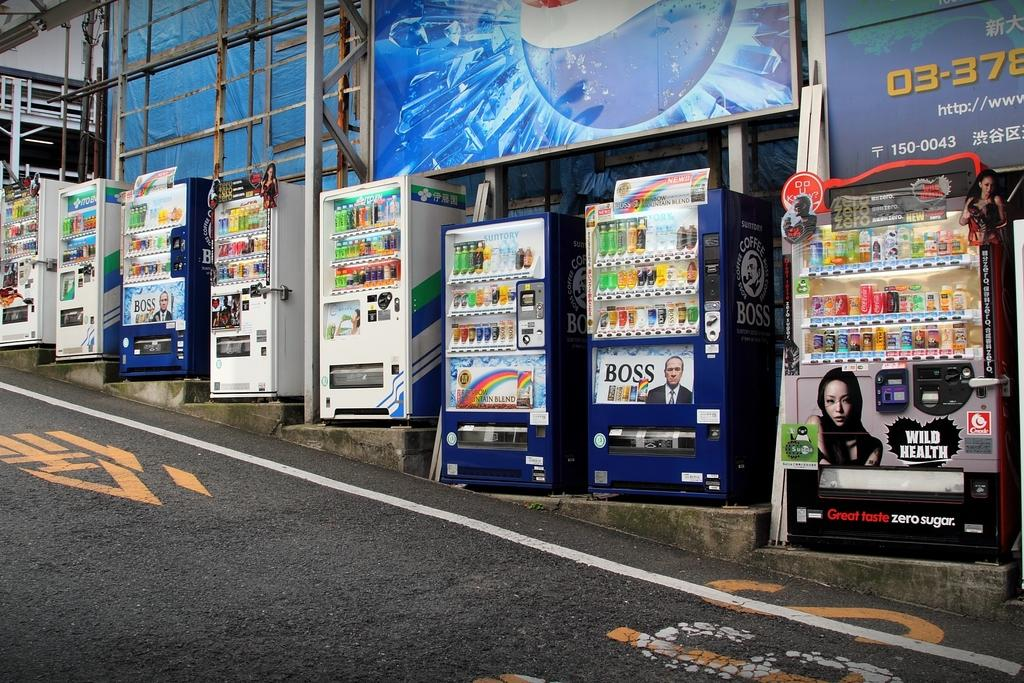<image>
Offer a succinct explanation of the picture presented. Several vending machines are lined up on a steep hill, one has an ad for Boss on it. 